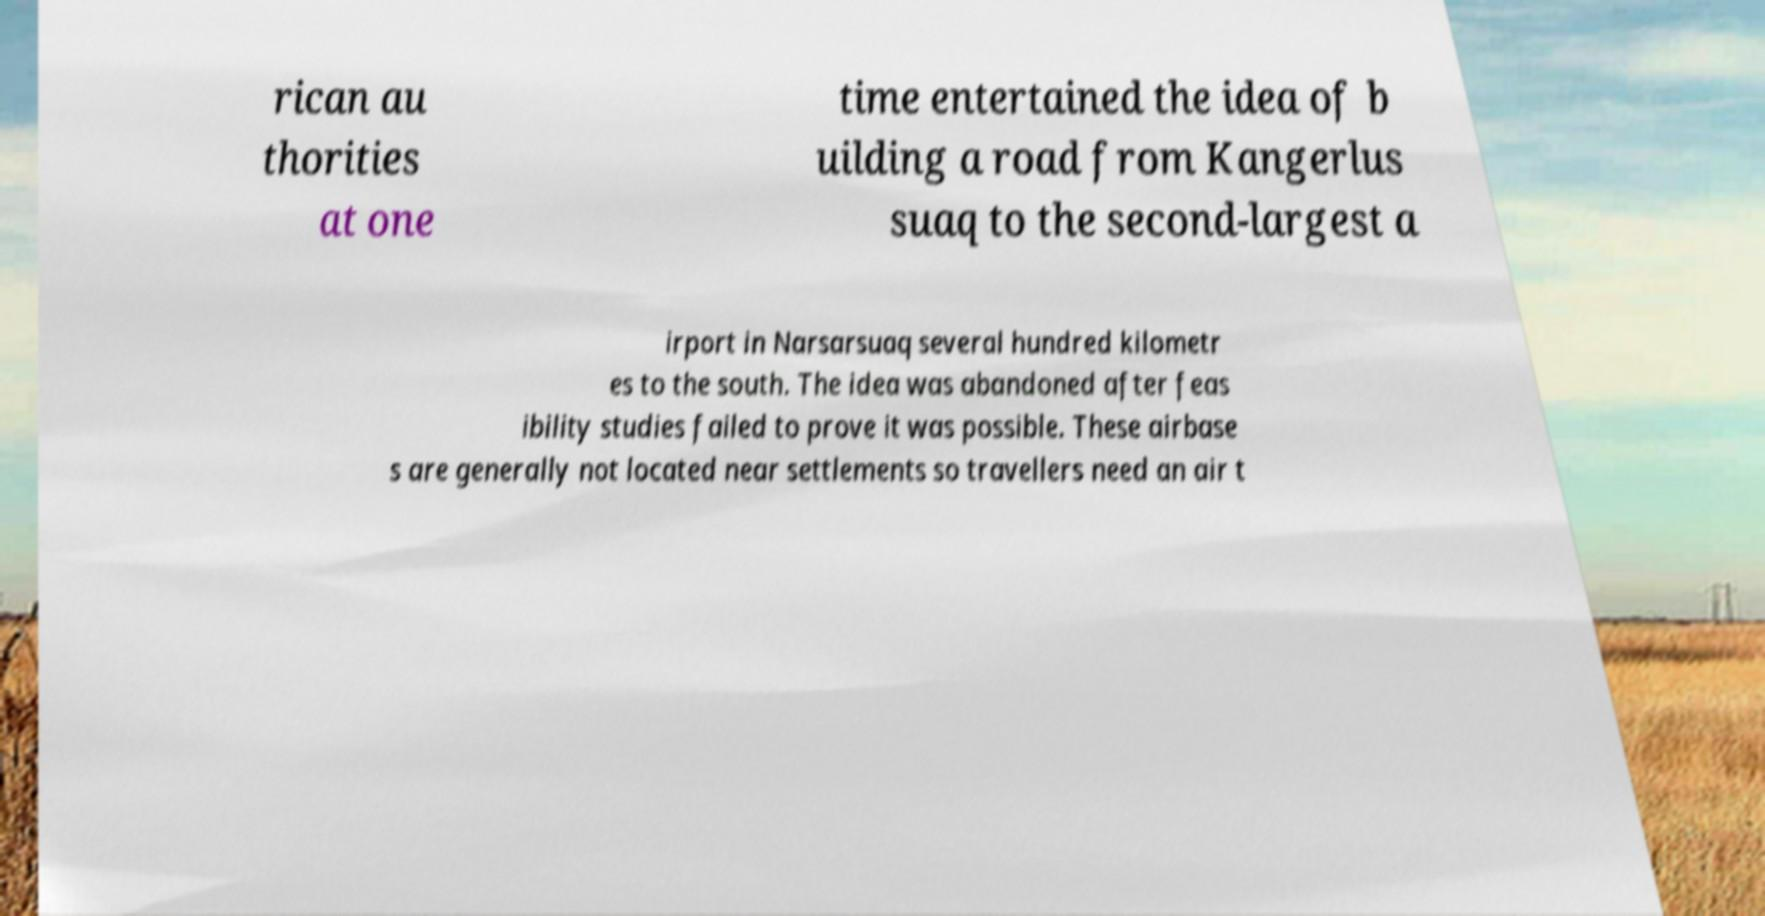For documentation purposes, I need the text within this image transcribed. Could you provide that? rican au thorities at one time entertained the idea of b uilding a road from Kangerlus suaq to the second-largest a irport in Narsarsuaq several hundred kilometr es to the south. The idea was abandoned after feas ibility studies failed to prove it was possible. These airbase s are generally not located near settlements so travellers need an air t 